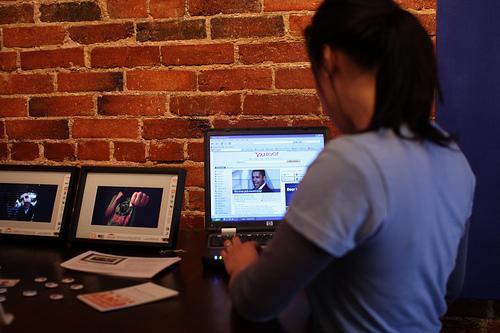How many laptops are there?
Give a very brief answer. 1. How many picture frames are on the table?
Give a very brief answer. 2. How many people are pictured?
Give a very brief answer. 1. How many frames are pictured?
Give a very brief answer. 2. 